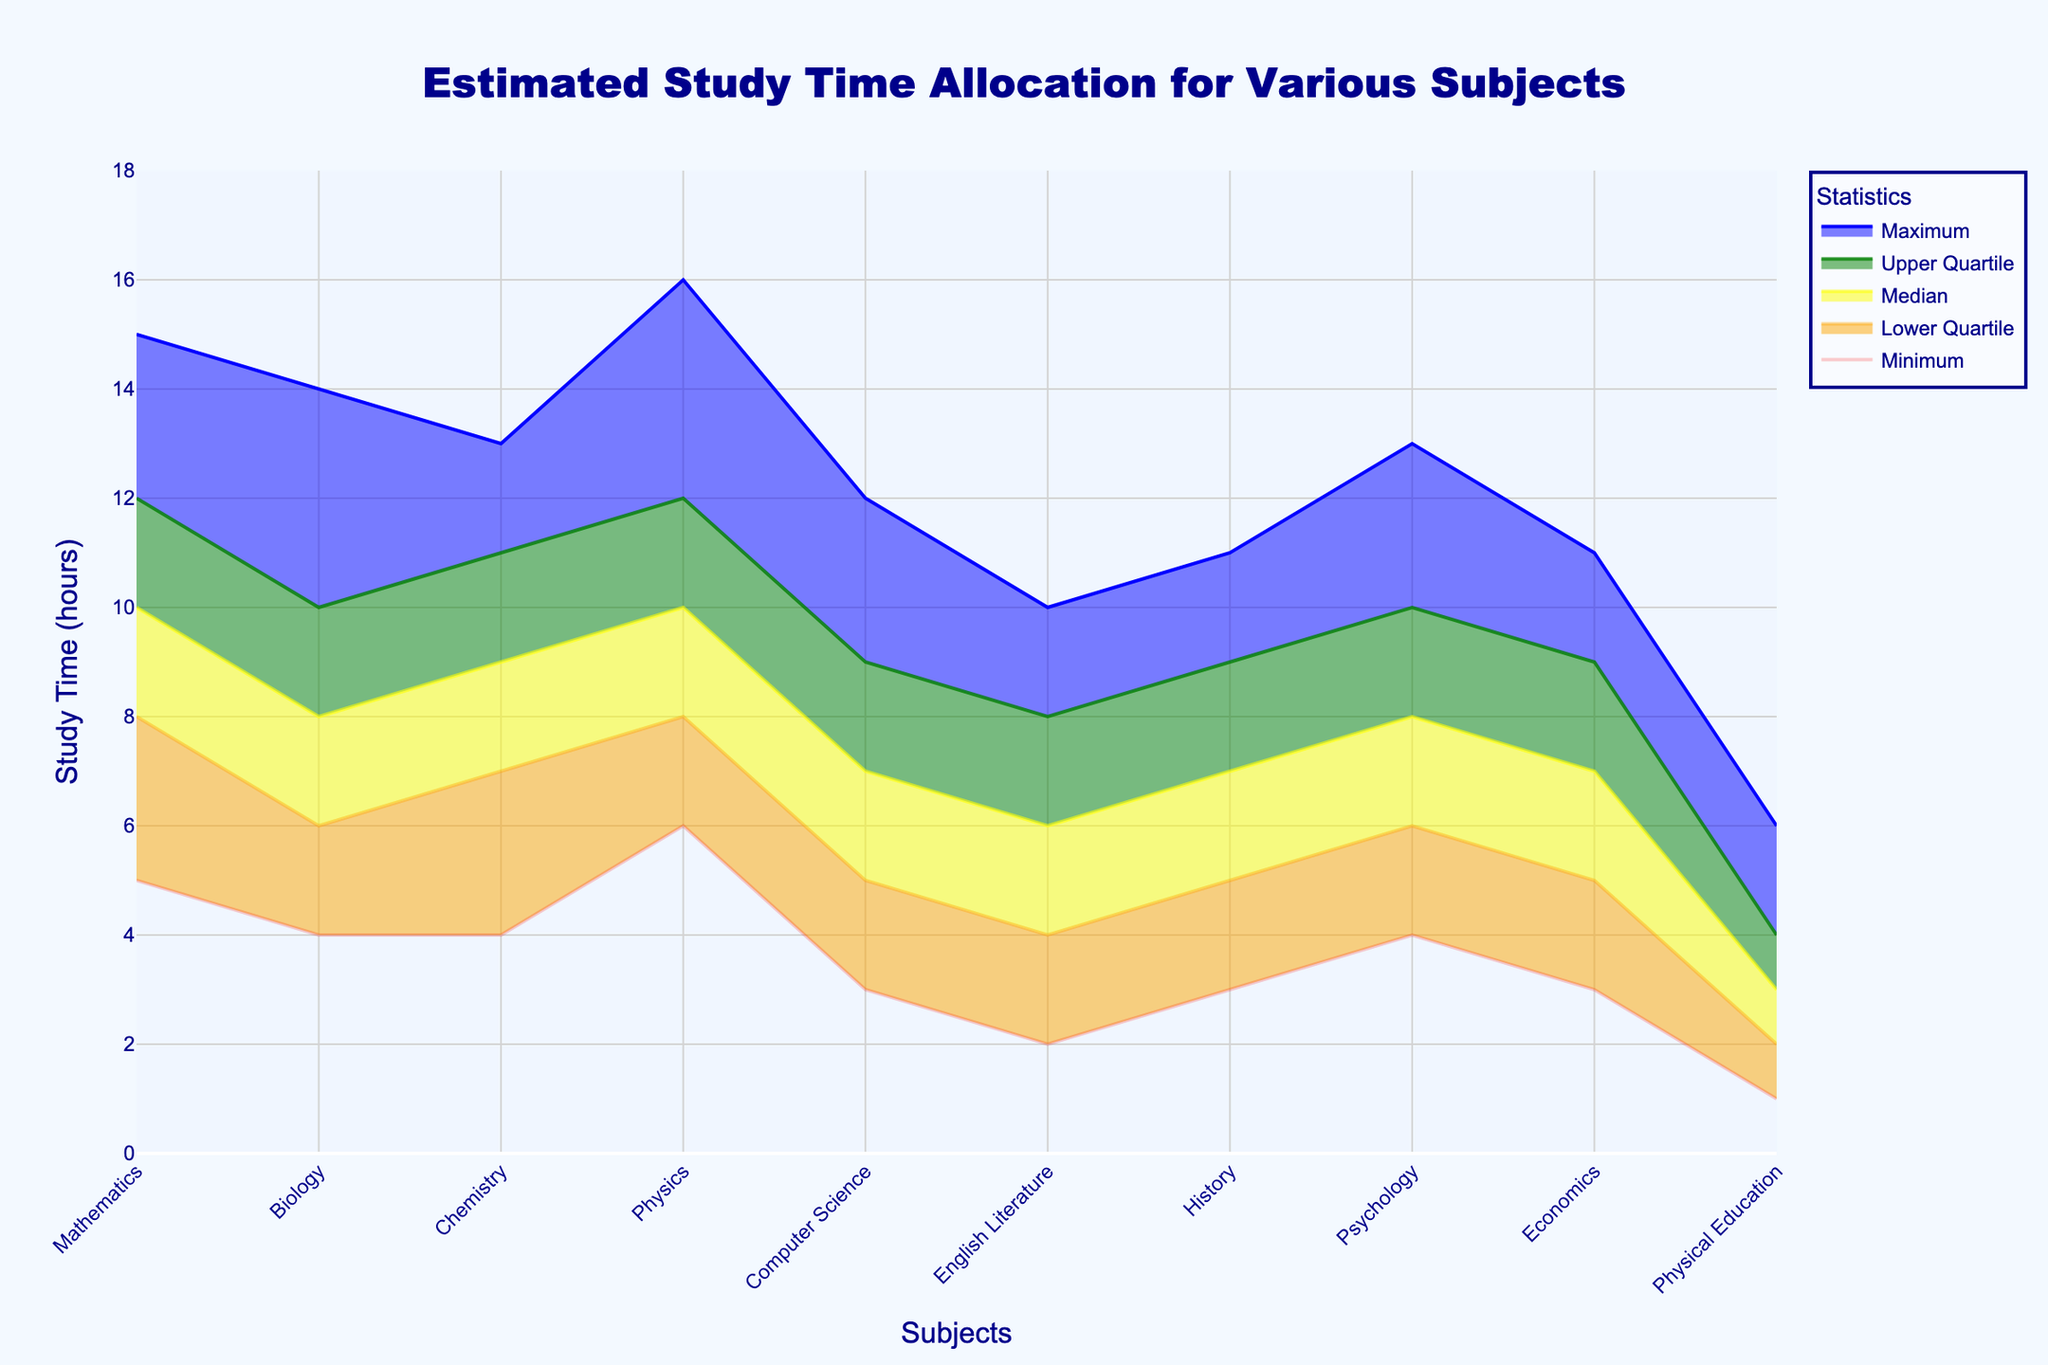Which subject has the lowest minimum study time? From the fan chart, the lowest "Minimum" value is associated with "Physical Education," which has a minimum study time of 1 hour.
Answer: Physical Education What is the difference between the maximum study time for Physics and Computer Science? The maximum study time for Physics is 16 hours and for Computer Science is 12 hours. The difference between them is 16 - 12 = 4 hours.
Answer: 4 hours Which subjects have a median study time of 8 hours? The fan chart shows that "Biology," "Physics," "Psychology," and "Economics" all have a median study time of 8 hours.
Answer: Biology, Physics, Psychology, Economics How does the upper quartile study time for Mathematics compare to Chemistry? The upper quartile study time for Mathematics is 12 hours and for Chemistry is 11 hours. Mathematics has a higher upper quartile study time than Chemistry.
Answer: Mathematics has a higher What is the range of study times for History? The range of study times is the difference between the maximum and minimum values. For History, the maximum is 11 hours and the minimum is 3 hours. Therefore, the range is 11 - 3 = 8 hours.
Answer: 8 hours Which subject has the highest study time range between its minimum and maximum? The highest study time range is seen in Physics, with a minimum study time of 6 hours and a maximum study time of 16 hours. Their difference is 16 - 6 = 10 hours.
Answer: Physics List the subjects that have a lower quartile study time of 6 hours. The subjects with a lower quartile study time of 6 hours are "Biology," "Psychology," and "Economics."
Answer: Biology, Psychology, Economics What is the median study time difference between Physical Education and Computer Science? The median study time for Physical Education is 3 hours, and for Computer Science, it is 7 hours. The difference is 7 - 3 = 4 hours.
Answer: 4 hours Which subject has the least upper quartile study time? The least upper quartile study time is in "Physical Education" with 4 hours.
Answer: Physical Education 